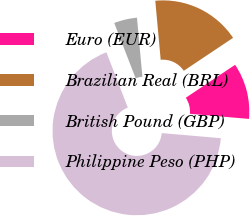<chart> <loc_0><loc_0><loc_500><loc_500><pie_chart><fcel>Euro (EUR)<fcel>Brazilian Real (BRL)<fcel>British Pound (GBP)<fcel>Philippine Peso (PHP)<nl><fcel>10.75%<fcel>17.08%<fcel>4.42%<fcel>67.75%<nl></chart> 